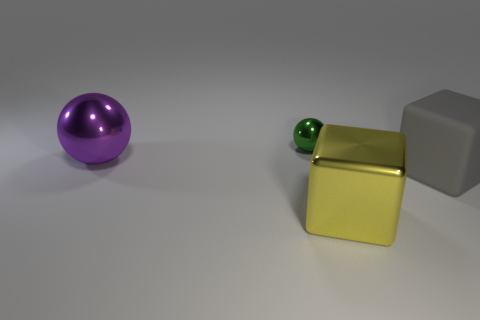Does the big matte object have the same color as the tiny ball?
Make the answer very short. No. There is another tiny shiny thing that is the same shape as the purple thing; what is its color?
Provide a short and direct response. Green. There is a object in front of the gray block; is its color the same as the large object that is behind the rubber object?
Your answer should be very brief. No. Is the number of yellow metal things that are to the right of the yellow block greater than the number of red rubber objects?
Make the answer very short. No. How many other things are there of the same size as the purple sphere?
Provide a short and direct response. 2. How many things are in front of the green metal ball and on the left side of the gray block?
Your answer should be compact. 2. Are the object that is in front of the gray thing and the purple object made of the same material?
Your answer should be compact. Yes. There is a thing right of the shiny object that is in front of the big block that is on the right side of the yellow metal object; what shape is it?
Provide a succinct answer. Cube. Are there an equal number of large gray cubes that are left of the purple shiny thing and blocks that are to the right of the big shiny block?
Offer a very short reply. No. There is another shiny block that is the same size as the gray block; what color is it?
Provide a succinct answer. Yellow. 